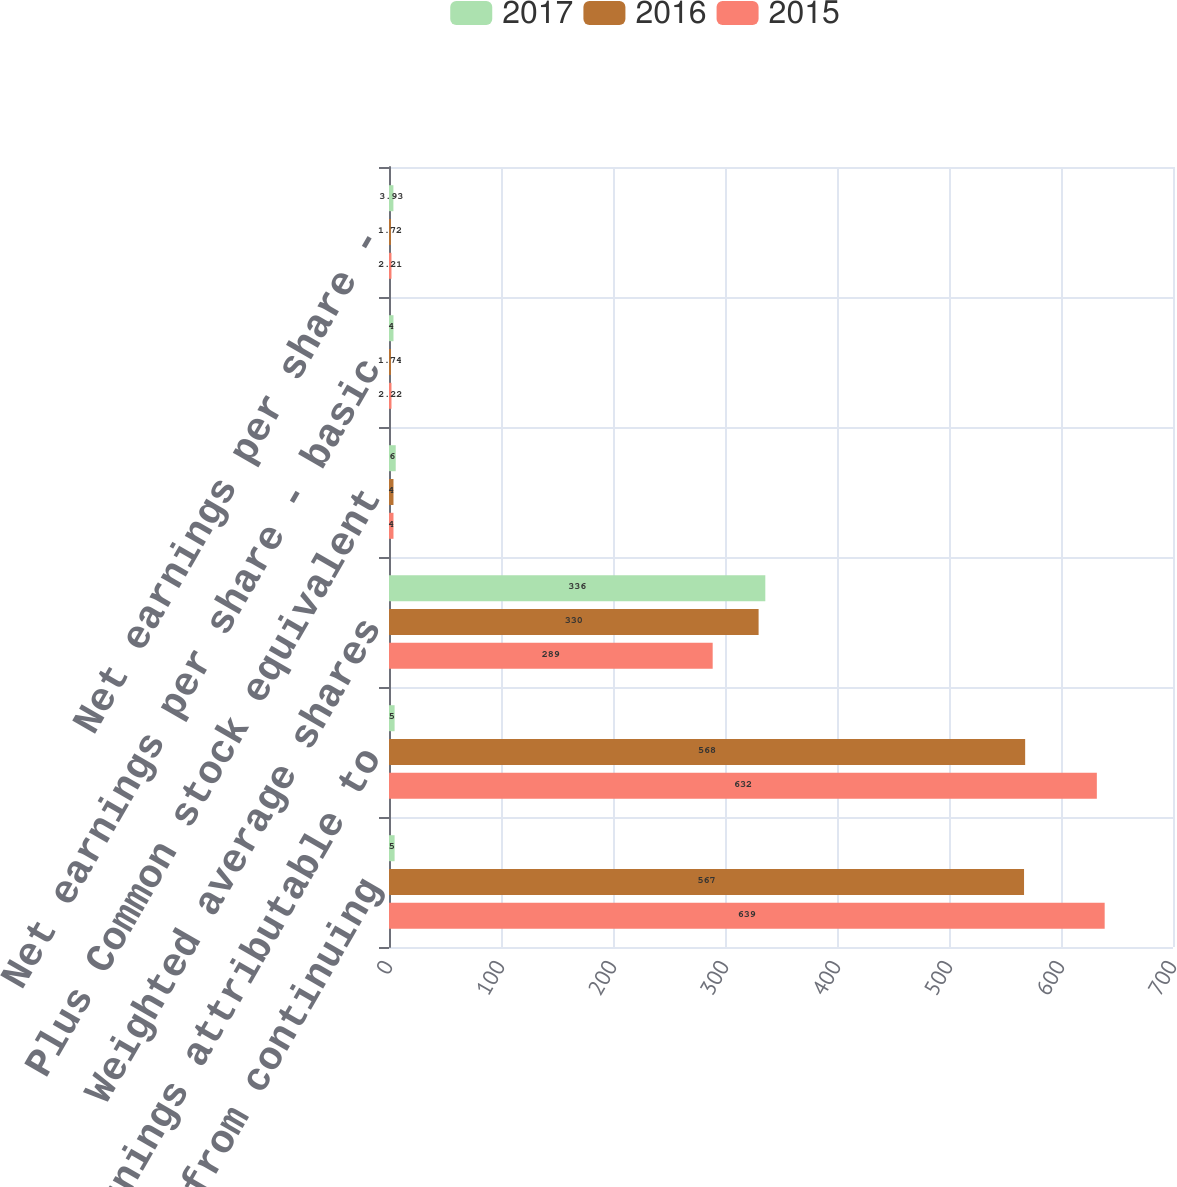Convert chart to OTSL. <chart><loc_0><loc_0><loc_500><loc_500><stacked_bar_chart><ecel><fcel>Earnings from continuing<fcel>Net earnings attributable to<fcel>Weighted average shares<fcel>Plus Common stock equivalent<fcel>Net earnings per share - basic<fcel>Net earnings per share -<nl><fcel>2017<fcel>5<fcel>5<fcel>336<fcel>6<fcel>4<fcel>3.93<nl><fcel>2016<fcel>567<fcel>568<fcel>330<fcel>4<fcel>1.74<fcel>1.72<nl><fcel>2015<fcel>639<fcel>632<fcel>289<fcel>4<fcel>2.22<fcel>2.21<nl></chart> 